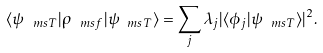<formula> <loc_0><loc_0><loc_500><loc_500>\langle \psi _ { \ m s { T } } | \rho _ { \ m s { f } } | \psi _ { \ m s { T } } \rangle = \sum _ { j } \lambda _ { j } | \langle \phi _ { j } | \psi _ { \ m s { T } } \rangle | ^ { 2 } .</formula> 